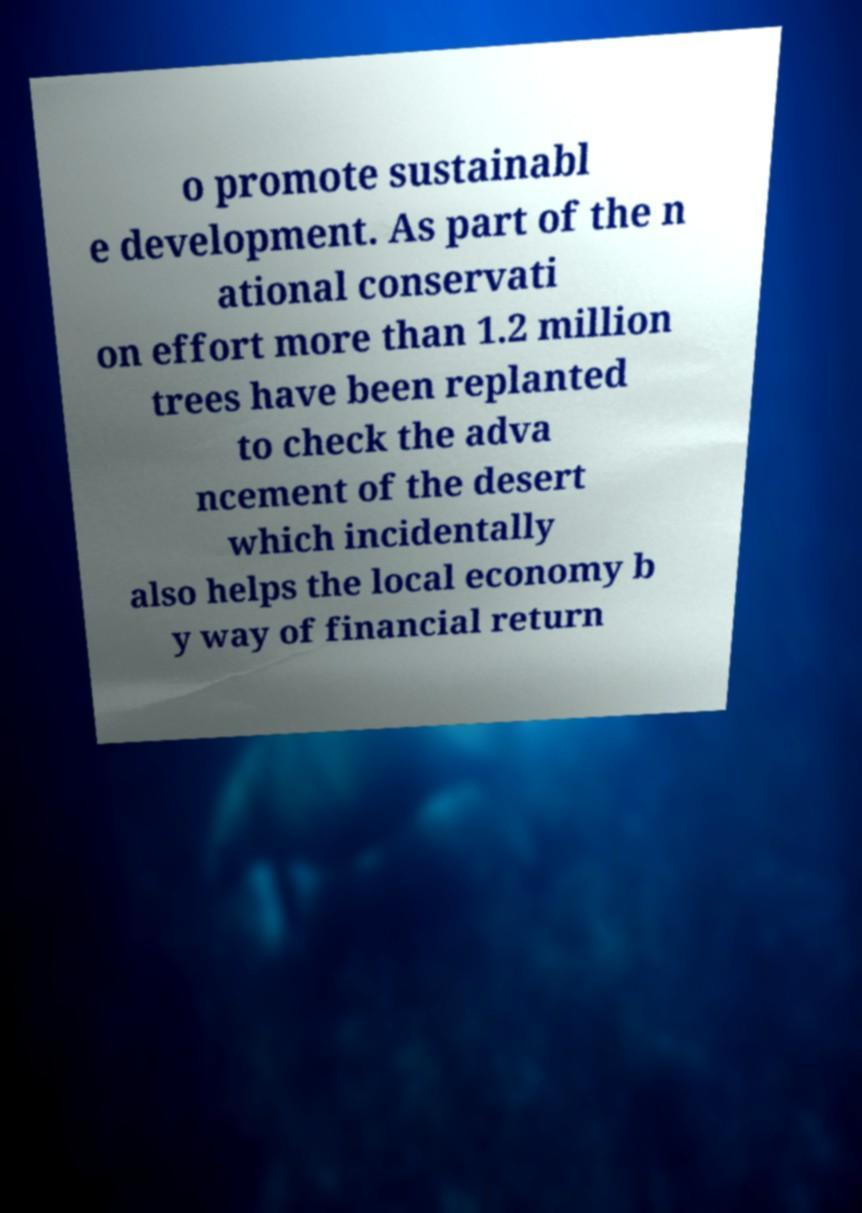Can you accurately transcribe the text from the provided image for me? o promote sustainabl e development. As part of the n ational conservati on effort more than 1.2 million trees have been replanted to check the adva ncement of the desert which incidentally also helps the local economy b y way of financial return 